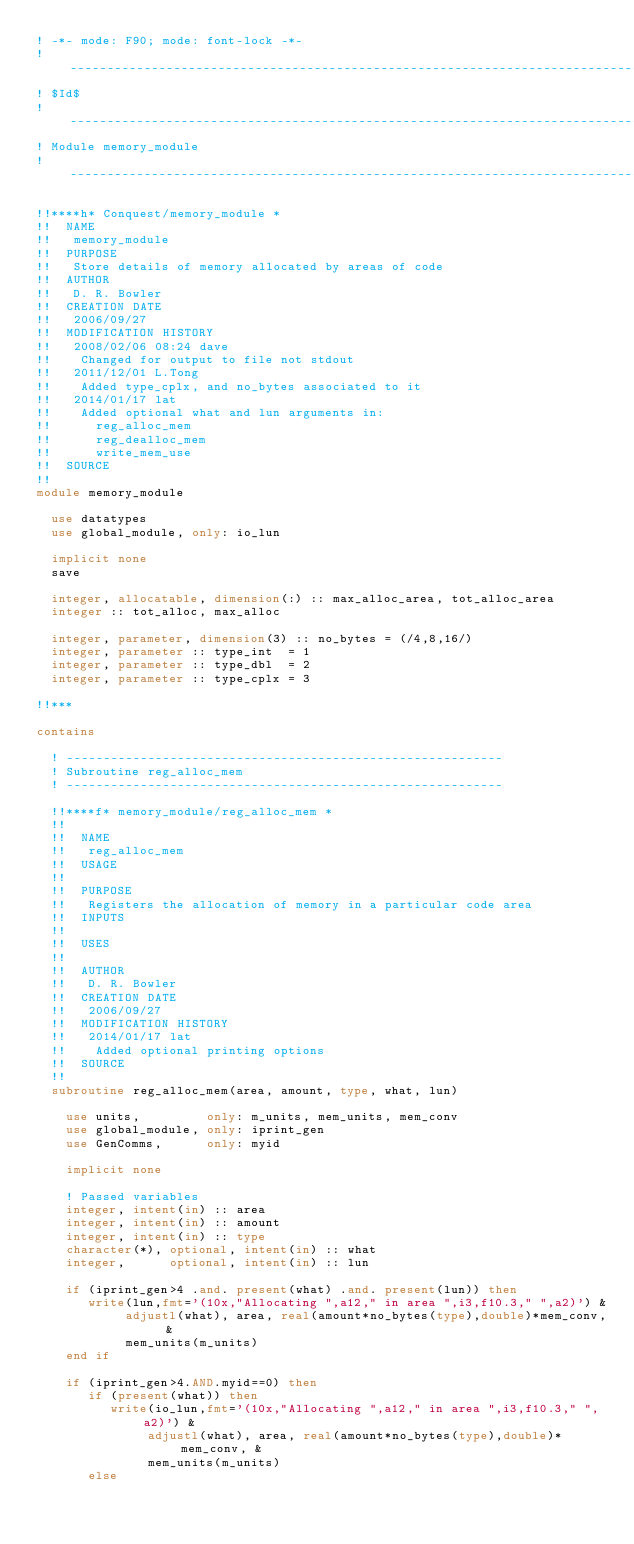<code> <loc_0><loc_0><loc_500><loc_500><_FORTRAN_>! -*- mode: F90; mode: font-lock -*-
! ------------------------------------------------------------------------------
! $Id$
! ------------------------------------------------------------------------------
! Module memory_module
! ------------------------------------------------------------------------------

!!****h* Conquest/memory_module *
!!  NAME
!!   memory_module
!!  PURPOSE
!!   Store details of memory allocated by areas of code
!!  AUTHOR
!!   D. R. Bowler
!!  CREATION DATE
!!   2006/09/27
!!  MODIFICATION HISTORY
!!   2008/02/06 08:24 dave
!!    Changed for output to file not stdout
!!   2011/12/01 L.Tong
!!    Added type_cplx, and no_bytes associated to it
!!   2014/01/17 lat 
!!    Added optional what and lun arguments in:
!!      reg_alloc_mem
!!      reg_dealloc_mem
!!      write_mem_use 
!!  SOURCE
!!
module memory_module

  use datatypes
  use global_module, only: io_lun

  implicit none
  save

  integer, allocatable, dimension(:) :: max_alloc_area, tot_alloc_area
  integer :: tot_alloc, max_alloc

  integer, parameter, dimension(3) :: no_bytes = (/4,8,16/)
  integer, parameter :: type_int  = 1
  integer, parameter :: type_dbl  = 2
  integer, parameter :: type_cplx = 3

!!***

contains

  ! -----------------------------------------------------------
  ! Subroutine reg_alloc_mem
  ! -----------------------------------------------------------

  !!****f* memory_module/reg_alloc_mem *
  !!
  !!  NAME
  !!   reg_alloc_mem
  !!  USAGE
  !!
  !!  PURPOSE
  !!   Registers the allocation of memory in a particular code area
  !!  INPUTS
  !!
  !!  USES
  !!
  !!  AUTHOR
  !!   D. R. Bowler
  !!  CREATION DATE
  !!   2006/09/27
  !!  MODIFICATION HISTORY
  !!   2014/01/17 lat 
  !!    Added optional printing options
  !!  SOURCE
  !!
  subroutine reg_alloc_mem(area, amount, type, what, lun)

    use units,         only: m_units, mem_units, mem_conv
    use global_module, only: iprint_gen
    use GenComms,      only: myid

    implicit none

    ! Passed variables
    integer, intent(in) :: area
    integer, intent(in) :: amount
    integer, intent(in) :: type
    character(*), optional, intent(in) :: what
    integer,      optional, intent(in) :: lun

    if (iprint_gen>4 .and. present(what) .and. present(lun)) then
       write(lun,fmt='(10x,"Allocating ",a12," in area ",i3,f10.3," ",a2)') &
            adjustl(what), area, real(amount*no_bytes(type),double)*mem_conv, &
            mem_units(m_units)
    end if

    if (iprint_gen>4.AND.myid==0) then
       if (present(what)) then
          write(io_lun,fmt='(10x,"Allocating ",a12," in area ",i3,f10.3," ",a2)') &
               adjustl(what), area, real(amount*no_bytes(type),double)*mem_conv, &
               mem_units(m_units)
       else</code> 